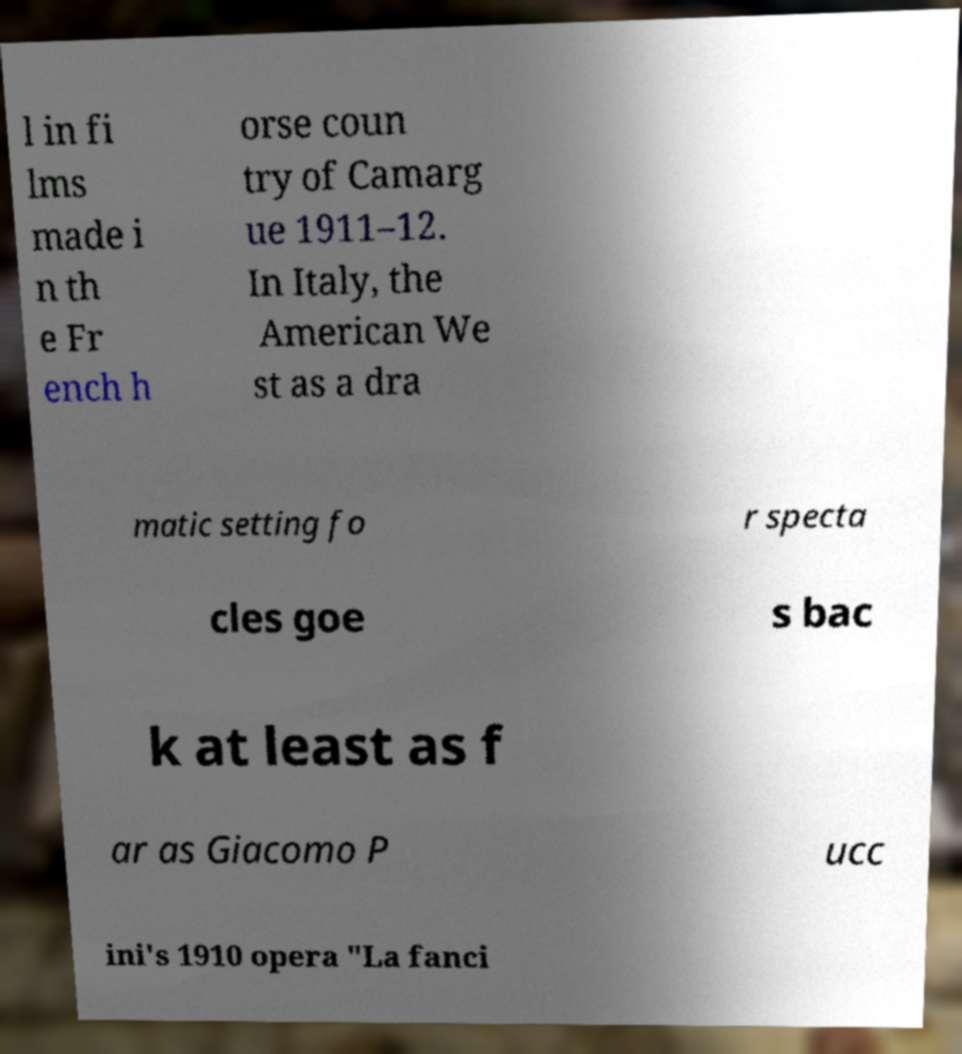There's text embedded in this image that I need extracted. Can you transcribe it verbatim? l in fi lms made i n th e Fr ench h orse coun try of Camarg ue 1911–12. In Italy, the American We st as a dra matic setting fo r specta cles goe s bac k at least as f ar as Giacomo P ucc ini's 1910 opera "La fanci 